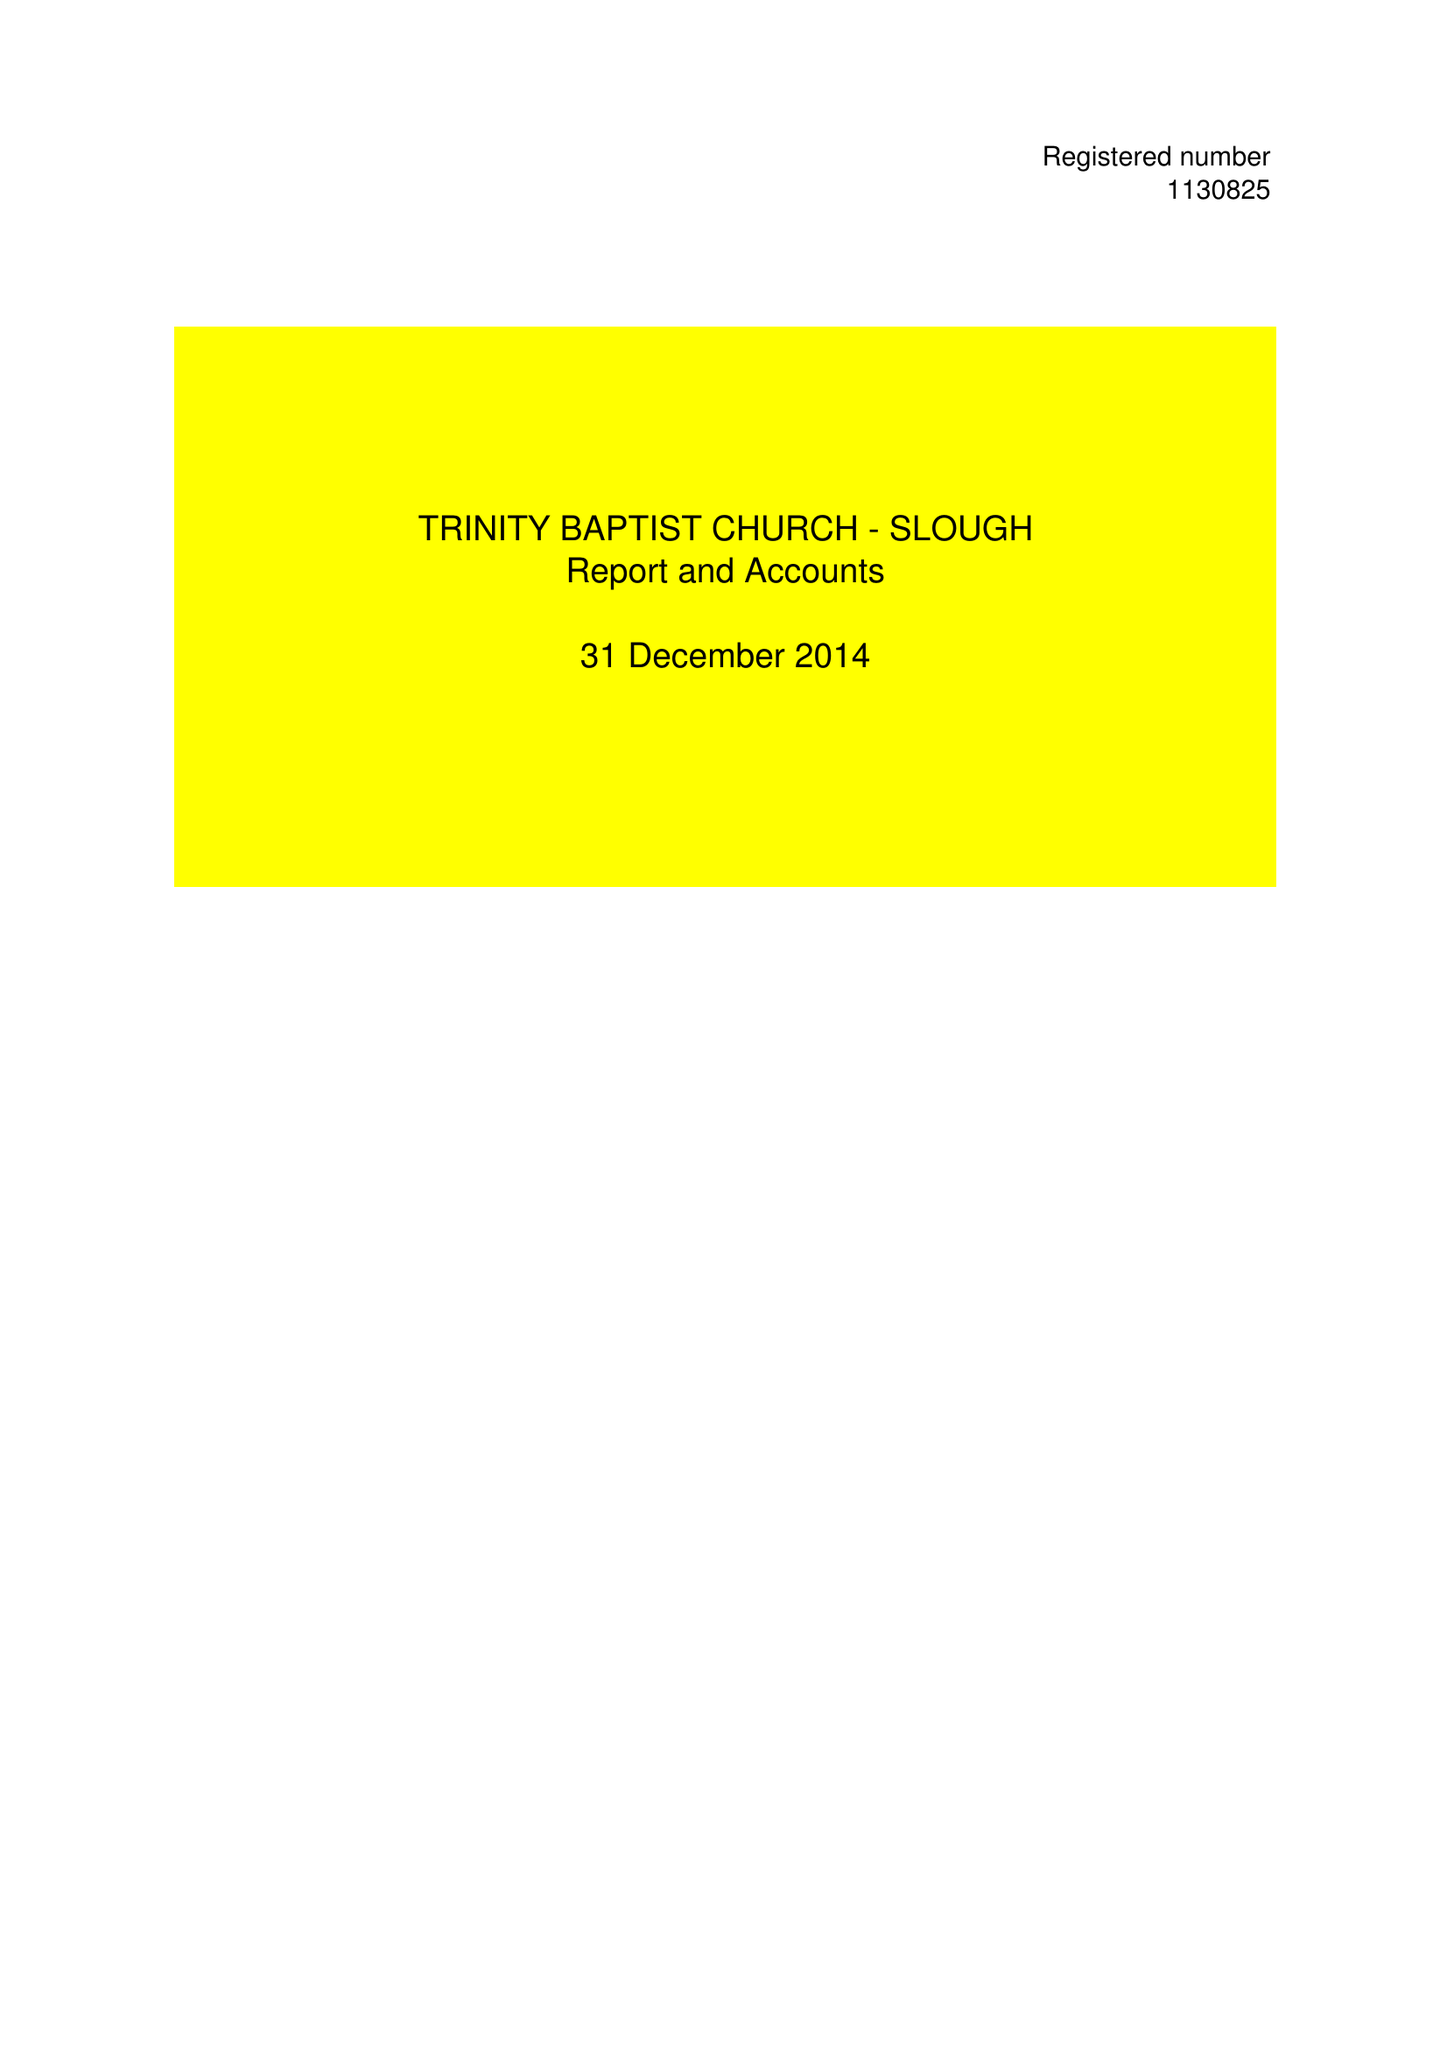What is the value for the address__postcode?
Answer the question using a single word or phrase. CR4 1XH 